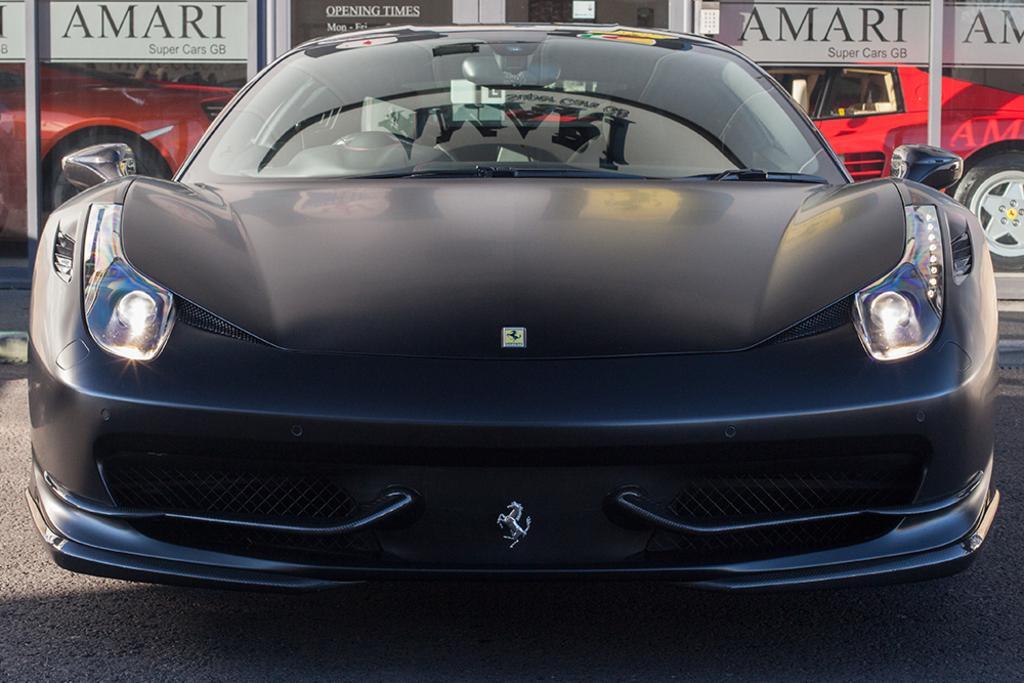Could you give a brief overview of what you see in this image? In this picture there is a car in the center of the image and there are other cars in the background area of the image. 